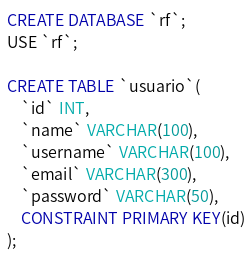Convert code to text. <code><loc_0><loc_0><loc_500><loc_500><_SQL_>CREATE DATABASE `rf`;
USE `rf`;

CREATE TABLE `usuario`(
    `id` INT,
	`name` VARCHAR(100),
    `username` VARCHAR(100),
    `email` VARCHAR(300),
    `password` VARCHAR(50), 
    CONSTRAINT PRIMARY KEY(id)
);</code> 